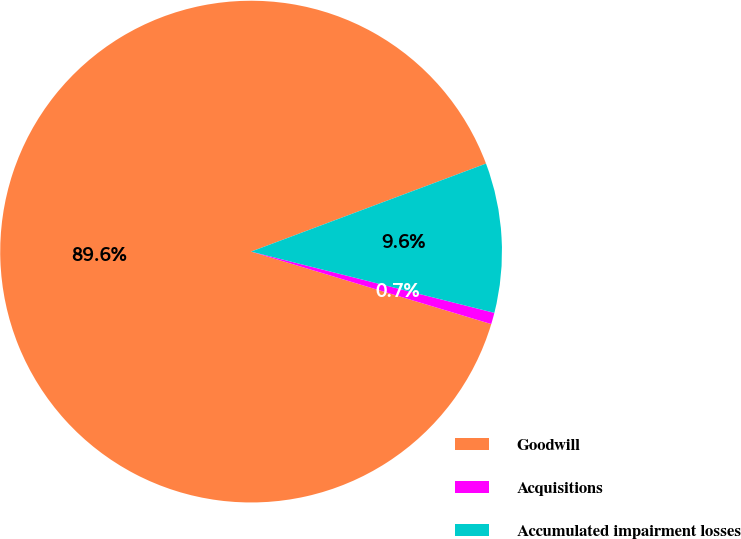<chart> <loc_0><loc_0><loc_500><loc_500><pie_chart><fcel>Goodwill<fcel>Acquisitions<fcel>Accumulated impairment losses<nl><fcel>89.63%<fcel>0.74%<fcel>9.63%<nl></chart> 